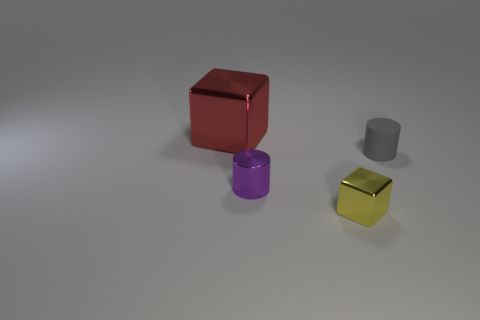There is a red shiny thing; is it the same size as the metallic block that is right of the large object?
Offer a very short reply. No. Is the cube that is behind the tiny purple thing made of the same material as the block that is right of the red metal cube?
Make the answer very short. Yes. Are there an equal number of red metal cubes that are to the right of the tiny gray rubber cylinder and yellow shiny cubes in front of the small shiny cylinder?
Your answer should be compact. No. What number of other big things are the same color as the big metallic thing?
Provide a succinct answer. 0. How many rubber things are either big cyan cylinders or yellow things?
Offer a terse response. 0. Is the shape of the metal object in front of the tiny purple metallic object the same as the thing that is behind the gray rubber thing?
Provide a succinct answer. Yes. What number of gray cylinders are behind the purple object?
Offer a very short reply. 1. Are there any tiny yellow cubes that have the same material as the large cube?
Keep it short and to the point. Yes. What is the material of the other cylinder that is the same size as the purple cylinder?
Offer a very short reply. Rubber. Is the purple cylinder made of the same material as the small gray cylinder?
Offer a very short reply. No. 